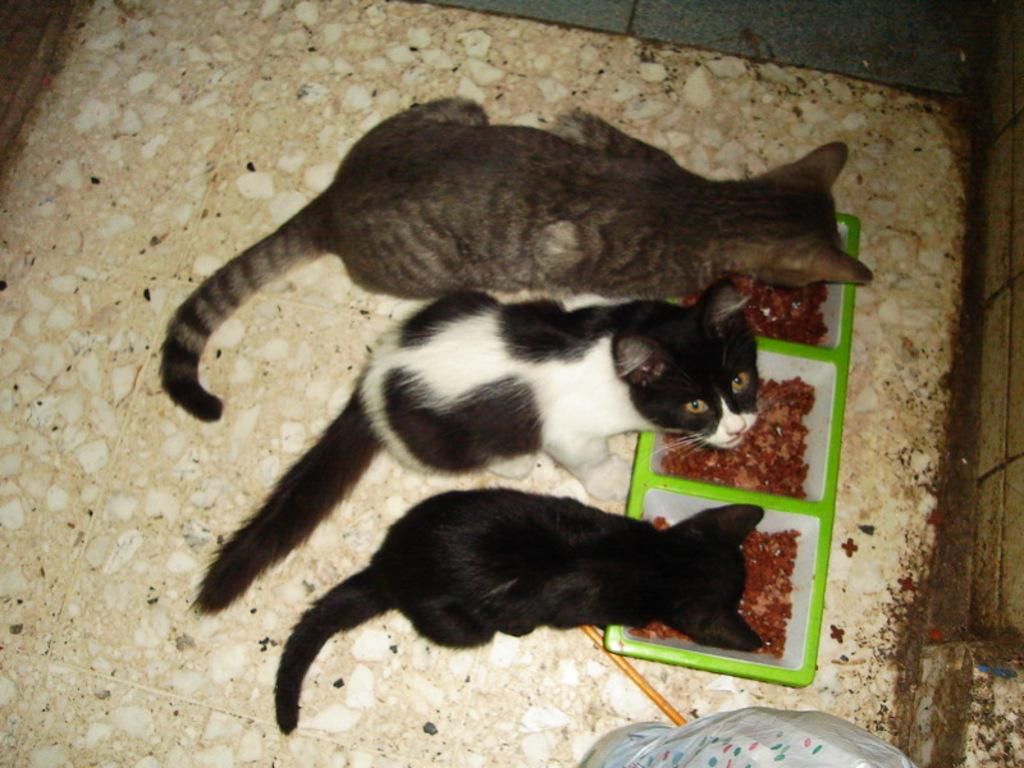How many cats are visible in the image? There are three cats in the image. What are the cats doing in the image? The information provided does not specify what the cats are doing. What can be found in the bowls in the image? There is food in bowls in the image. What object is present in the image that is not related to the cats or their food? There is a stick in the image. What type of produce can be seen on the shelf in the image? There is no shelf or produce present in the image. 